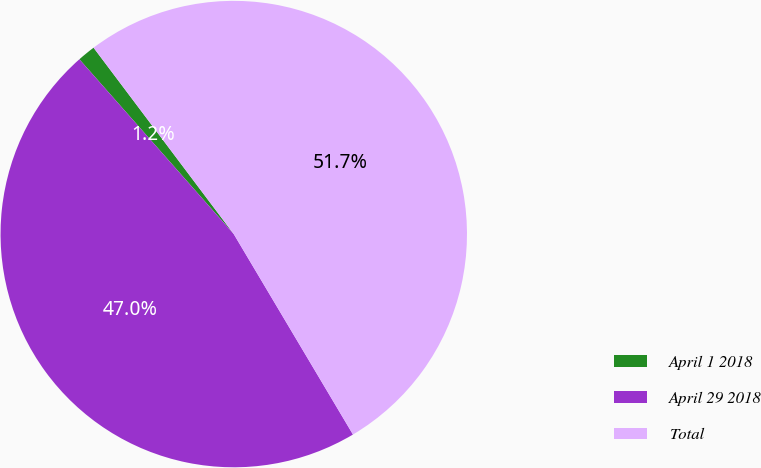<chart> <loc_0><loc_0><loc_500><loc_500><pie_chart><fcel>April 1 2018<fcel>April 29 2018<fcel>Total<nl><fcel>1.25%<fcel>47.03%<fcel>51.73%<nl></chart> 